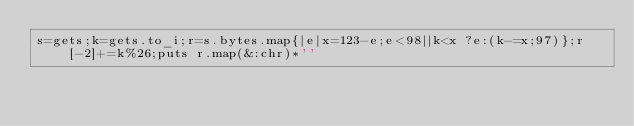Convert code to text. <code><loc_0><loc_0><loc_500><loc_500><_Ruby_>s=gets;k=gets.to_i;r=s.bytes.map{|e|x=123-e;e<98||k<x ?e:(k-=x;97)};r[-2]+=k%26;puts r.map(&:chr)*''</code> 